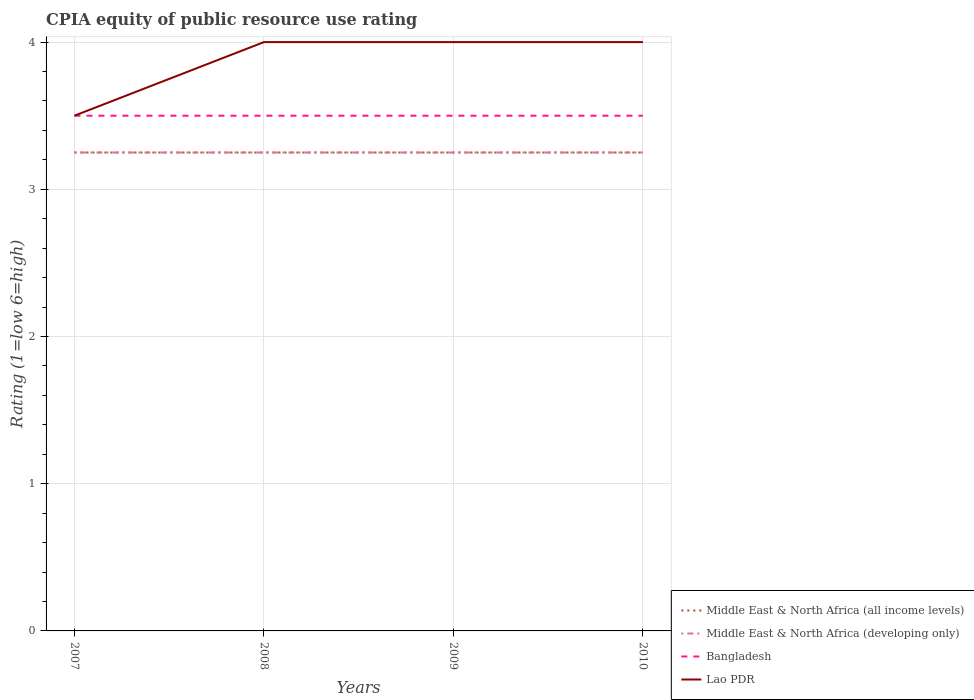Does the line corresponding to Bangladesh intersect with the line corresponding to Lao PDR?
Keep it short and to the point. Yes. Across all years, what is the maximum CPIA rating in Lao PDR?
Offer a very short reply. 3.5. In which year was the CPIA rating in Middle East & North Africa (all income levels) maximum?
Offer a very short reply. 2007. What is the difference between the highest and the lowest CPIA rating in Middle East & North Africa (developing only)?
Make the answer very short. 0. Is the CPIA rating in Lao PDR strictly greater than the CPIA rating in Middle East & North Africa (all income levels) over the years?
Keep it short and to the point. No. How many years are there in the graph?
Provide a short and direct response. 4. What is the difference between two consecutive major ticks on the Y-axis?
Provide a short and direct response. 1. Where does the legend appear in the graph?
Make the answer very short. Bottom right. How many legend labels are there?
Offer a very short reply. 4. What is the title of the graph?
Provide a succinct answer. CPIA equity of public resource use rating. What is the label or title of the X-axis?
Provide a short and direct response. Years. What is the label or title of the Y-axis?
Keep it short and to the point. Rating (1=low 6=high). What is the Rating (1=low 6=high) of Middle East & North Africa (all income levels) in 2007?
Offer a very short reply. 3.25. What is the Rating (1=low 6=high) of Middle East & North Africa (developing only) in 2007?
Your response must be concise. 3.25. What is the Rating (1=low 6=high) in Middle East & North Africa (all income levels) in 2008?
Provide a succinct answer. 3.25. What is the Rating (1=low 6=high) of Lao PDR in 2008?
Offer a terse response. 4. What is the Rating (1=low 6=high) of Middle East & North Africa (developing only) in 2009?
Your response must be concise. 3.25. What is the Rating (1=low 6=high) of Bangladesh in 2009?
Ensure brevity in your answer.  3.5. What is the Rating (1=low 6=high) in Lao PDR in 2009?
Offer a very short reply. 4. What is the Rating (1=low 6=high) in Middle East & North Africa (all income levels) in 2010?
Your answer should be very brief. 3.25. What is the Rating (1=low 6=high) of Middle East & North Africa (developing only) in 2010?
Keep it short and to the point. 3.25. Across all years, what is the maximum Rating (1=low 6=high) in Middle East & North Africa (developing only)?
Offer a very short reply. 3.25. Across all years, what is the maximum Rating (1=low 6=high) in Lao PDR?
Ensure brevity in your answer.  4. Across all years, what is the minimum Rating (1=low 6=high) of Middle East & North Africa (developing only)?
Your answer should be compact. 3.25. What is the total Rating (1=low 6=high) in Middle East & North Africa (all income levels) in the graph?
Keep it short and to the point. 13. What is the total Rating (1=low 6=high) in Bangladesh in the graph?
Provide a short and direct response. 14. What is the total Rating (1=low 6=high) in Lao PDR in the graph?
Make the answer very short. 15.5. What is the difference between the Rating (1=low 6=high) in Middle East & North Africa (all income levels) in 2007 and that in 2008?
Make the answer very short. 0. What is the difference between the Rating (1=low 6=high) in Middle East & North Africa (developing only) in 2007 and that in 2008?
Your answer should be compact. 0. What is the difference between the Rating (1=low 6=high) of Lao PDR in 2007 and that in 2008?
Provide a short and direct response. -0.5. What is the difference between the Rating (1=low 6=high) in Middle East & North Africa (developing only) in 2007 and that in 2009?
Provide a short and direct response. 0. What is the difference between the Rating (1=low 6=high) in Bangladesh in 2007 and that in 2009?
Provide a succinct answer. 0. What is the difference between the Rating (1=low 6=high) of Lao PDR in 2008 and that in 2009?
Give a very brief answer. 0. What is the difference between the Rating (1=low 6=high) of Middle East & North Africa (all income levels) in 2008 and that in 2010?
Give a very brief answer. 0. What is the difference between the Rating (1=low 6=high) of Middle East & North Africa (developing only) in 2008 and that in 2010?
Keep it short and to the point. 0. What is the difference between the Rating (1=low 6=high) in Middle East & North Africa (all income levels) in 2009 and that in 2010?
Provide a short and direct response. 0. What is the difference between the Rating (1=low 6=high) in Middle East & North Africa (developing only) in 2009 and that in 2010?
Give a very brief answer. 0. What is the difference between the Rating (1=low 6=high) in Bangladesh in 2009 and that in 2010?
Make the answer very short. 0. What is the difference between the Rating (1=low 6=high) of Middle East & North Africa (all income levels) in 2007 and the Rating (1=low 6=high) of Middle East & North Africa (developing only) in 2008?
Keep it short and to the point. 0. What is the difference between the Rating (1=low 6=high) in Middle East & North Africa (all income levels) in 2007 and the Rating (1=low 6=high) in Bangladesh in 2008?
Offer a very short reply. -0.25. What is the difference between the Rating (1=low 6=high) in Middle East & North Africa (all income levels) in 2007 and the Rating (1=low 6=high) in Lao PDR in 2008?
Keep it short and to the point. -0.75. What is the difference between the Rating (1=low 6=high) in Middle East & North Africa (developing only) in 2007 and the Rating (1=low 6=high) in Lao PDR in 2008?
Your response must be concise. -0.75. What is the difference between the Rating (1=low 6=high) of Middle East & North Africa (all income levels) in 2007 and the Rating (1=low 6=high) of Lao PDR in 2009?
Offer a terse response. -0.75. What is the difference between the Rating (1=low 6=high) in Middle East & North Africa (developing only) in 2007 and the Rating (1=low 6=high) in Lao PDR in 2009?
Make the answer very short. -0.75. What is the difference between the Rating (1=low 6=high) of Bangladesh in 2007 and the Rating (1=low 6=high) of Lao PDR in 2009?
Give a very brief answer. -0.5. What is the difference between the Rating (1=low 6=high) of Middle East & North Africa (all income levels) in 2007 and the Rating (1=low 6=high) of Lao PDR in 2010?
Provide a succinct answer. -0.75. What is the difference between the Rating (1=low 6=high) of Middle East & North Africa (developing only) in 2007 and the Rating (1=low 6=high) of Lao PDR in 2010?
Your answer should be compact. -0.75. What is the difference between the Rating (1=low 6=high) of Bangladesh in 2007 and the Rating (1=low 6=high) of Lao PDR in 2010?
Your answer should be very brief. -0.5. What is the difference between the Rating (1=low 6=high) of Middle East & North Africa (all income levels) in 2008 and the Rating (1=low 6=high) of Lao PDR in 2009?
Ensure brevity in your answer.  -0.75. What is the difference between the Rating (1=low 6=high) of Middle East & North Africa (developing only) in 2008 and the Rating (1=low 6=high) of Lao PDR in 2009?
Your answer should be very brief. -0.75. What is the difference between the Rating (1=low 6=high) of Bangladesh in 2008 and the Rating (1=low 6=high) of Lao PDR in 2009?
Your answer should be very brief. -0.5. What is the difference between the Rating (1=low 6=high) of Middle East & North Africa (all income levels) in 2008 and the Rating (1=low 6=high) of Middle East & North Africa (developing only) in 2010?
Your answer should be very brief. 0. What is the difference between the Rating (1=low 6=high) in Middle East & North Africa (all income levels) in 2008 and the Rating (1=low 6=high) in Lao PDR in 2010?
Your answer should be very brief. -0.75. What is the difference between the Rating (1=low 6=high) in Middle East & North Africa (developing only) in 2008 and the Rating (1=low 6=high) in Lao PDR in 2010?
Your response must be concise. -0.75. What is the difference between the Rating (1=low 6=high) in Middle East & North Africa (all income levels) in 2009 and the Rating (1=low 6=high) in Middle East & North Africa (developing only) in 2010?
Offer a very short reply. 0. What is the difference between the Rating (1=low 6=high) in Middle East & North Africa (all income levels) in 2009 and the Rating (1=low 6=high) in Lao PDR in 2010?
Offer a terse response. -0.75. What is the difference between the Rating (1=low 6=high) of Middle East & North Africa (developing only) in 2009 and the Rating (1=low 6=high) of Lao PDR in 2010?
Your response must be concise. -0.75. What is the average Rating (1=low 6=high) in Middle East & North Africa (all income levels) per year?
Your answer should be compact. 3.25. What is the average Rating (1=low 6=high) of Middle East & North Africa (developing only) per year?
Provide a short and direct response. 3.25. What is the average Rating (1=low 6=high) in Lao PDR per year?
Your answer should be compact. 3.88. In the year 2007, what is the difference between the Rating (1=low 6=high) of Middle East & North Africa (all income levels) and Rating (1=low 6=high) of Bangladesh?
Offer a very short reply. -0.25. In the year 2007, what is the difference between the Rating (1=low 6=high) in Middle East & North Africa (developing only) and Rating (1=low 6=high) in Bangladesh?
Your answer should be compact. -0.25. In the year 2007, what is the difference between the Rating (1=low 6=high) of Bangladesh and Rating (1=low 6=high) of Lao PDR?
Your answer should be compact. 0. In the year 2008, what is the difference between the Rating (1=low 6=high) in Middle East & North Africa (all income levels) and Rating (1=low 6=high) in Middle East & North Africa (developing only)?
Give a very brief answer. 0. In the year 2008, what is the difference between the Rating (1=low 6=high) in Middle East & North Africa (all income levels) and Rating (1=low 6=high) in Bangladesh?
Your answer should be compact. -0.25. In the year 2008, what is the difference between the Rating (1=low 6=high) of Middle East & North Africa (all income levels) and Rating (1=low 6=high) of Lao PDR?
Your response must be concise. -0.75. In the year 2008, what is the difference between the Rating (1=low 6=high) in Middle East & North Africa (developing only) and Rating (1=low 6=high) in Lao PDR?
Provide a succinct answer. -0.75. In the year 2009, what is the difference between the Rating (1=low 6=high) in Middle East & North Africa (all income levels) and Rating (1=low 6=high) in Lao PDR?
Your answer should be very brief. -0.75. In the year 2009, what is the difference between the Rating (1=low 6=high) in Middle East & North Africa (developing only) and Rating (1=low 6=high) in Lao PDR?
Give a very brief answer. -0.75. In the year 2010, what is the difference between the Rating (1=low 6=high) of Middle East & North Africa (all income levels) and Rating (1=low 6=high) of Middle East & North Africa (developing only)?
Your answer should be very brief. 0. In the year 2010, what is the difference between the Rating (1=low 6=high) in Middle East & North Africa (all income levels) and Rating (1=low 6=high) in Bangladesh?
Ensure brevity in your answer.  -0.25. In the year 2010, what is the difference between the Rating (1=low 6=high) of Middle East & North Africa (all income levels) and Rating (1=low 6=high) of Lao PDR?
Make the answer very short. -0.75. In the year 2010, what is the difference between the Rating (1=low 6=high) in Middle East & North Africa (developing only) and Rating (1=low 6=high) in Lao PDR?
Offer a terse response. -0.75. In the year 2010, what is the difference between the Rating (1=low 6=high) of Bangladesh and Rating (1=low 6=high) of Lao PDR?
Ensure brevity in your answer.  -0.5. What is the ratio of the Rating (1=low 6=high) in Lao PDR in 2007 to that in 2009?
Provide a succinct answer. 0.88. What is the ratio of the Rating (1=low 6=high) of Middle East & North Africa (all income levels) in 2007 to that in 2010?
Your response must be concise. 1. What is the ratio of the Rating (1=low 6=high) in Middle East & North Africa (developing only) in 2007 to that in 2010?
Your answer should be compact. 1. What is the ratio of the Rating (1=low 6=high) in Lao PDR in 2007 to that in 2010?
Give a very brief answer. 0.88. What is the ratio of the Rating (1=low 6=high) of Middle East & North Africa (all income levels) in 2008 to that in 2009?
Offer a terse response. 1. What is the ratio of the Rating (1=low 6=high) of Middle East & North Africa (developing only) in 2008 to that in 2009?
Your answer should be very brief. 1. What is the ratio of the Rating (1=low 6=high) in Middle East & North Africa (all income levels) in 2008 to that in 2010?
Your answer should be compact. 1. What is the ratio of the Rating (1=low 6=high) of Middle East & North Africa (developing only) in 2008 to that in 2010?
Your answer should be compact. 1. What is the ratio of the Rating (1=low 6=high) of Lao PDR in 2008 to that in 2010?
Offer a terse response. 1. What is the ratio of the Rating (1=low 6=high) in Middle East & North Africa (all income levels) in 2009 to that in 2010?
Provide a short and direct response. 1. What is the ratio of the Rating (1=low 6=high) of Lao PDR in 2009 to that in 2010?
Your answer should be compact. 1. What is the difference between the highest and the second highest Rating (1=low 6=high) of Middle East & North Africa (developing only)?
Give a very brief answer. 0. What is the difference between the highest and the second highest Rating (1=low 6=high) in Lao PDR?
Make the answer very short. 0. What is the difference between the highest and the lowest Rating (1=low 6=high) in Middle East & North Africa (all income levels)?
Offer a very short reply. 0. What is the difference between the highest and the lowest Rating (1=low 6=high) in Bangladesh?
Ensure brevity in your answer.  0. What is the difference between the highest and the lowest Rating (1=low 6=high) of Lao PDR?
Keep it short and to the point. 0.5. 